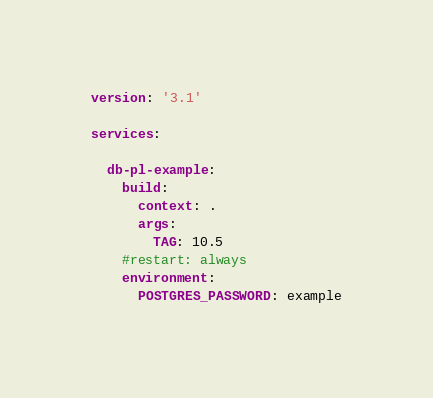Convert code to text. <code><loc_0><loc_0><loc_500><loc_500><_YAML_>version: '3.1'

services:

  db-pl-example:
    build:
      context: .
      args:
        TAG: 10.5
    #restart: always
    environment:
      POSTGRES_PASSWORD: example
</code> 